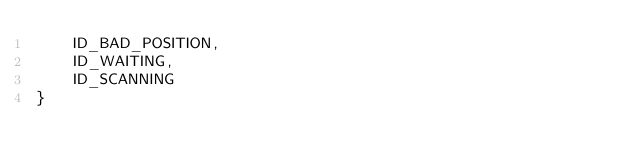<code> <loc_0><loc_0><loc_500><loc_500><_Kotlin_>    ID_BAD_POSITION,
    ID_WAITING,
    ID_SCANNING
}</code> 